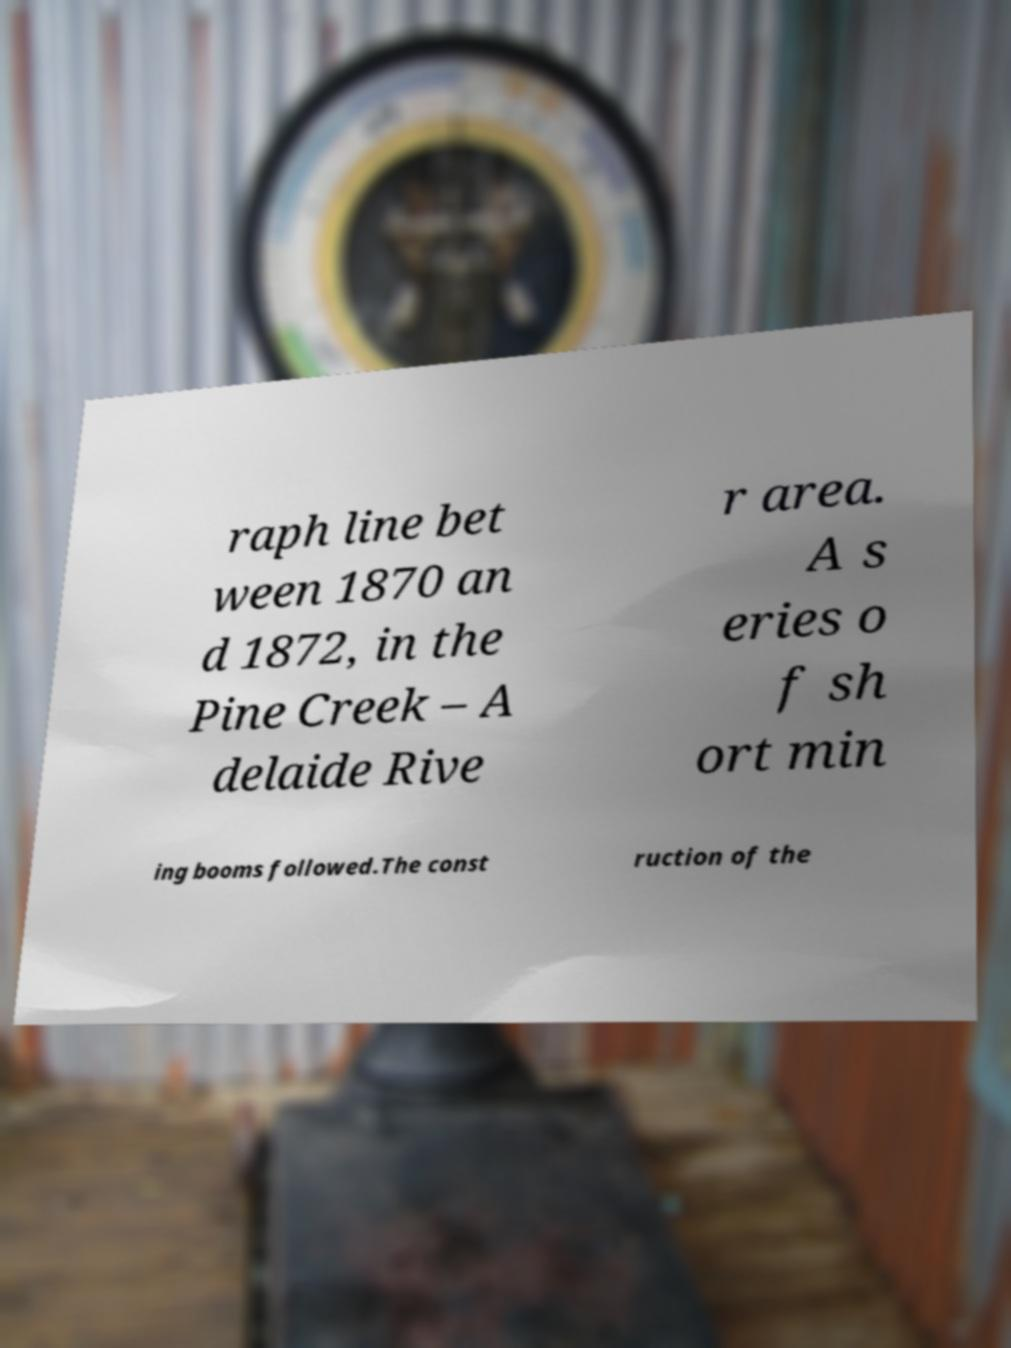Can you accurately transcribe the text from the provided image for me? raph line bet ween 1870 an d 1872, in the Pine Creek – A delaide Rive r area. A s eries o f sh ort min ing booms followed.The const ruction of the 